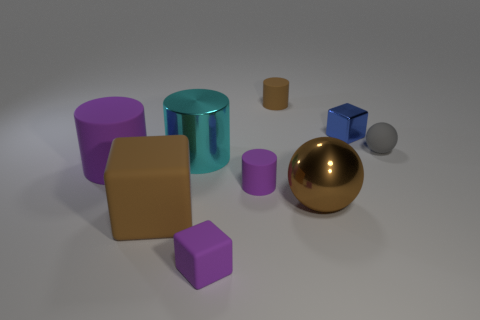Subtract all tiny cubes. How many cubes are left? 1 Subtract 0 blue cylinders. How many objects are left? 9 Subtract all blocks. How many objects are left? 6 Subtract 1 cylinders. How many cylinders are left? 3 Subtract all cyan balls. Subtract all green cylinders. How many balls are left? 2 Subtract all red balls. How many cyan cubes are left? 0 Subtract all cyan cylinders. Subtract all gray rubber spheres. How many objects are left? 7 Add 6 blocks. How many blocks are left? 9 Add 4 metallic objects. How many metallic objects exist? 7 Add 1 brown balls. How many objects exist? 10 